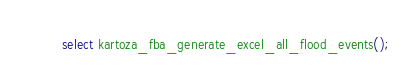Convert code to text. <code><loc_0><loc_0><loc_500><loc_500><_SQL_>
select kartoza_fba_generate_excel_all_flood_events();
</code> 